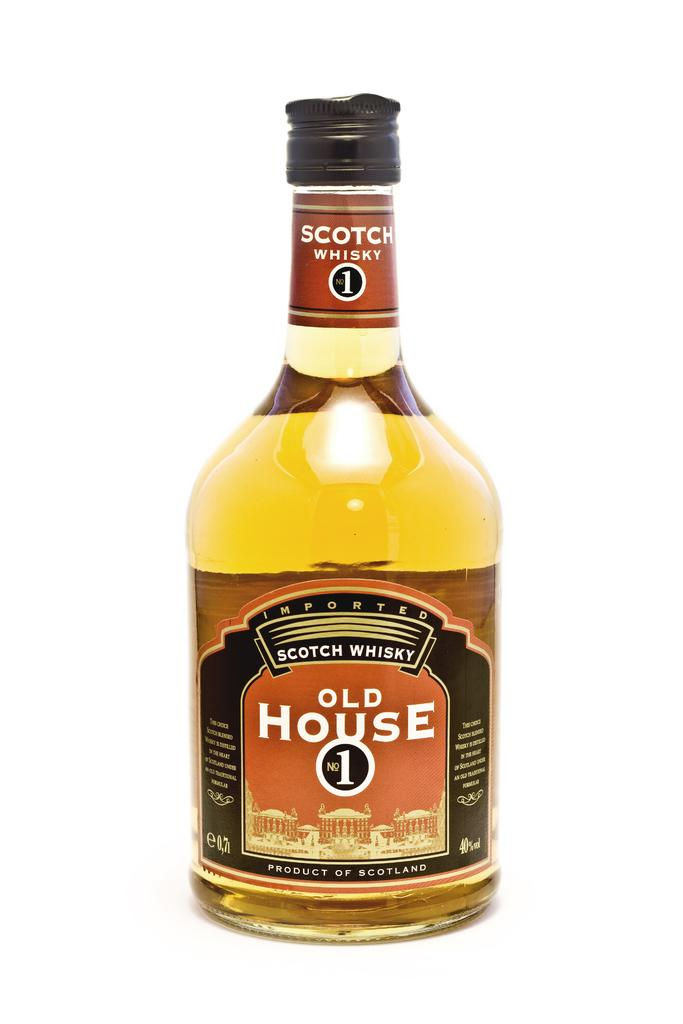<image>
Create a compact narrative representing the image presented. A simple picture of a full bottle of Old House No.1 whisky. 